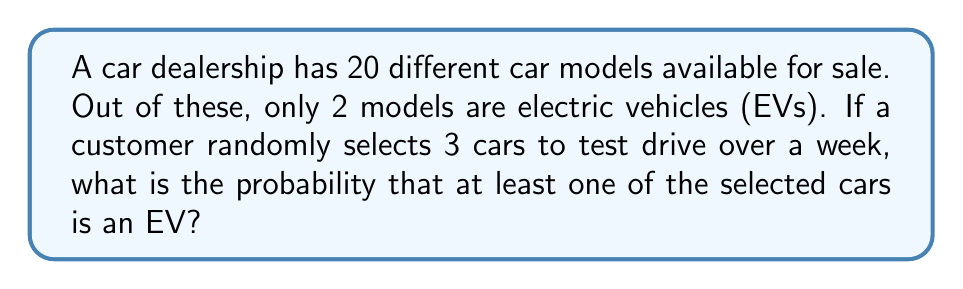Give your solution to this math problem. Let's approach this step-by-step:

1) First, we need to calculate the total number of ways to select 3 cars out of 20. This is a combination problem, denoted as $\binom{20}{3}$.

   $$\binom{20}{3} = \frac{20!}{3!(20-3)!} = \frac{20!}{3!17!} = 1140$$

2) Now, instead of calculating the probability of selecting at least one EV, it's easier to calculate the probability of selecting no EVs and then subtract this from 1.

3) To select no EVs, we need to choose all 3 cars from the 18 non-EV models. This can be done in $\binom{18}{3}$ ways.

   $$\binom{18}{3} = \frac{18!}{3!15!} = 816$$

4) The probability of selecting no EVs is:

   $$P(\text{no EVs}) = \frac{\binom{18}{3}}{\binom{20}{3}} = \frac{816}{1140} = \frac{68}{95}$$

5) Therefore, the probability of selecting at least one EV is:

   $$P(\text{at least one EV}) = 1 - P(\text{no EVs}) = 1 - \frac{68}{95} = \frac{27}{95}$$

6) This can be simplified to:

   $$\frac{27}{95} \approx 0.2842 \text{ or about } 28.42\%$$
Answer: $\frac{27}{95}$ 